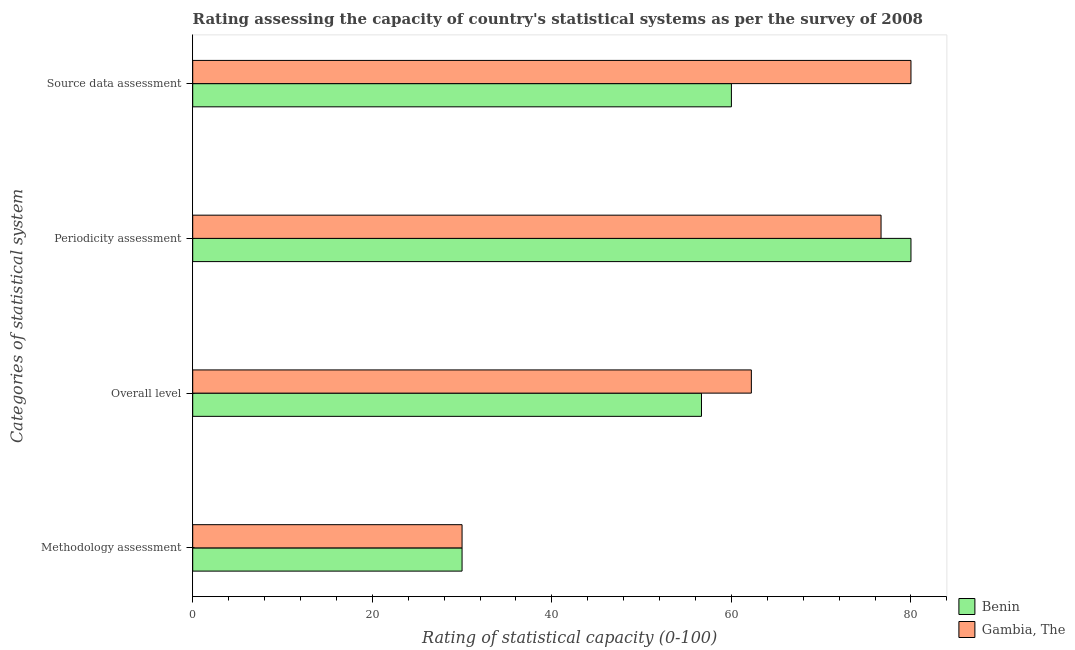How many groups of bars are there?
Offer a terse response. 4. Are the number of bars per tick equal to the number of legend labels?
Your answer should be very brief. Yes. Are the number of bars on each tick of the Y-axis equal?
Ensure brevity in your answer.  Yes. How many bars are there on the 4th tick from the top?
Offer a very short reply. 2. How many bars are there on the 2nd tick from the bottom?
Keep it short and to the point. 2. What is the label of the 4th group of bars from the top?
Make the answer very short. Methodology assessment. What is the source data assessment rating in Benin?
Offer a terse response. 60. Across all countries, what is the maximum overall level rating?
Your response must be concise. 62.22. Across all countries, what is the minimum periodicity assessment rating?
Your answer should be compact. 76.67. In which country was the periodicity assessment rating maximum?
Make the answer very short. Benin. In which country was the methodology assessment rating minimum?
Keep it short and to the point. Benin. What is the difference between the overall level rating in Benin and that in Gambia, The?
Your response must be concise. -5.56. What is the difference between the methodology assessment rating in Gambia, The and the overall level rating in Benin?
Provide a short and direct response. -26.67. What is the average overall level rating per country?
Provide a succinct answer. 59.44. What is the difference between the periodicity assessment rating and source data assessment rating in Benin?
Ensure brevity in your answer.  20. Is the difference between the overall level rating in Gambia, The and Benin greater than the difference between the periodicity assessment rating in Gambia, The and Benin?
Provide a short and direct response. Yes. What is the difference between the highest and the lowest overall level rating?
Offer a very short reply. 5.56. What does the 2nd bar from the top in Overall level represents?
Provide a short and direct response. Benin. What does the 2nd bar from the bottom in Source data assessment represents?
Your answer should be very brief. Gambia, The. How many bars are there?
Make the answer very short. 8. Are all the bars in the graph horizontal?
Your answer should be very brief. Yes. How many countries are there in the graph?
Make the answer very short. 2. What is the difference between two consecutive major ticks on the X-axis?
Your answer should be very brief. 20. What is the title of the graph?
Offer a terse response. Rating assessing the capacity of country's statistical systems as per the survey of 2008 . Does "Maldives" appear as one of the legend labels in the graph?
Ensure brevity in your answer.  No. What is the label or title of the X-axis?
Your answer should be very brief. Rating of statistical capacity (0-100). What is the label or title of the Y-axis?
Your answer should be compact. Categories of statistical system. What is the Rating of statistical capacity (0-100) of Benin in Methodology assessment?
Offer a very short reply. 30. What is the Rating of statistical capacity (0-100) in Benin in Overall level?
Your response must be concise. 56.67. What is the Rating of statistical capacity (0-100) in Gambia, The in Overall level?
Your response must be concise. 62.22. What is the Rating of statistical capacity (0-100) in Benin in Periodicity assessment?
Provide a short and direct response. 80. What is the Rating of statistical capacity (0-100) in Gambia, The in Periodicity assessment?
Keep it short and to the point. 76.67. Across all Categories of statistical system, what is the minimum Rating of statistical capacity (0-100) in Gambia, The?
Make the answer very short. 30. What is the total Rating of statistical capacity (0-100) in Benin in the graph?
Provide a succinct answer. 226.67. What is the total Rating of statistical capacity (0-100) of Gambia, The in the graph?
Provide a succinct answer. 248.89. What is the difference between the Rating of statistical capacity (0-100) in Benin in Methodology assessment and that in Overall level?
Your answer should be compact. -26.67. What is the difference between the Rating of statistical capacity (0-100) of Gambia, The in Methodology assessment and that in Overall level?
Your answer should be very brief. -32.22. What is the difference between the Rating of statistical capacity (0-100) of Gambia, The in Methodology assessment and that in Periodicity assessment?
Make the answer very short. -46.67. What is the difference between the Rating of statistical capacity (0-100) in Benin in Methodology assessment and that in Source data assessment?
Give a very brief answer. -30. What is the difference between the Rating of statistical capacity (0-100) of Gambia, The in Methodology assessment and that in Source data assessment?
Your answer should be very brief. -50. What is the difference between the Rating of statistical capacity (0-100) of Benin in Overall level and that in Periodicity assessment?
Offer a very short reply. -23.33. What is the difference between the Rating of statistical capacity (0-100) of Gambia, The in Overall level and that in Periodicity assessment?
Give a very brief answer. -14.44. What is the difference between the Rating of statistical capacity (0-100) of Benin in Overall level and that in Source data assessment?
Offer a terse response. -3.33. What is the difference between the Rating of statistical capacity (0-100) in Gambia, The in Overall level and that in Source data assessment?
Your response must be concise. -17.78. What is the difference between the Rating of statistical capacity (0-100) in Benin in Periodicity assessment and that in Source data assessment?
Make the answer very short. 20. What is the difference between the Rating of statistical capacity (0-100) in Gambia, The in Periodicity assessment and that in Source data assessment?
Offer a very short reply. -3.33. What is the difference between the Rating of statistical capacity (0-100) in Benin in Methodology assessment and the Rating of statistical capacity (0-100) in Gambia, The in Overall level?
Make the answer very short. -32.22. What is the difference between the Rating of statistical capacity (0-100) in Benin in Methodology assessment and the Rating of statistical capacity (0-100) in Gambia, The in Periodicity assessment?
Your response must be concise. -46.67. What is the difference between the Rating of statistical capacity (0-100) of Benin in Overall level and the Rating of statistical capacity (0-100) of Gambia, The in Source data assessment?
Your response must be concise. -23.33. What is the average Rating of statistical capacity (0-100) of Benin per Categories of statistical system?
Provide a short and direct response. 56.67. What is the average Rating of statistical capacity (0-100) in Gambia, The per Categories of statistical system?
Make the answer very short. 62.22. What is the difference between the Rating of statistical capacity (0-100) of Benin and Rating of statistical capacity (0-100) of Gambia, The in Overall level?
Your response must be concise. -5.56. What is the difference between the Rating of statistical capacity (0-100) of Benin and Rating of statistical capacity (0-100) of Gambia, The in Periodicity assessment?
Offer a terse response. 3.33. What is the ratio of the Rating of statistical capacity (0-100) of Benin in Methodology assessment to that in Overall level?
Provide a short and direct response. 0.53. What is the ratio of the Rating of statistical capacity (0-100) in Gambia, The in Methodology assessment to that in Overall level?
Offer a very short reply. 0.48. What is the ratio of the Rating of statistical capacity (0-100) in Benin in Methodology assessment to that in Periodicity assessment?
Keep it short and to the point. 0.38. What is the ratio of the Rating of statistical capacity (0-100) in Gambia, The in Methodology assessment to that in Periodicity assessment?
Provide a short and direct response. 0.39. What is the ratio of the Rating of statistical capacity (0-100) of Benin in Methodology assessment to that in Source data assessment?
Keep it short and to the point. 0.5. What is the ratio of the Rating of statistical capacity (0-100) of Benin in Overall level to that in Periodicity assessment?
Provide a short and direct response. 0.71. What is the ratio of the Rating of statistical capacity (0-100) of Gambia, The in Overall level to that in Periodicity assessment?
Give a very brief answer. 0.81. What is the difference between the highest and the second highest Rating of statistical capacity (0-100) in Gambia, The?
Your response must be concise. 3.33. 